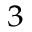<formula> <loc_0><loc_0><loc_500><loc_500>^ { 3 }</formula> 